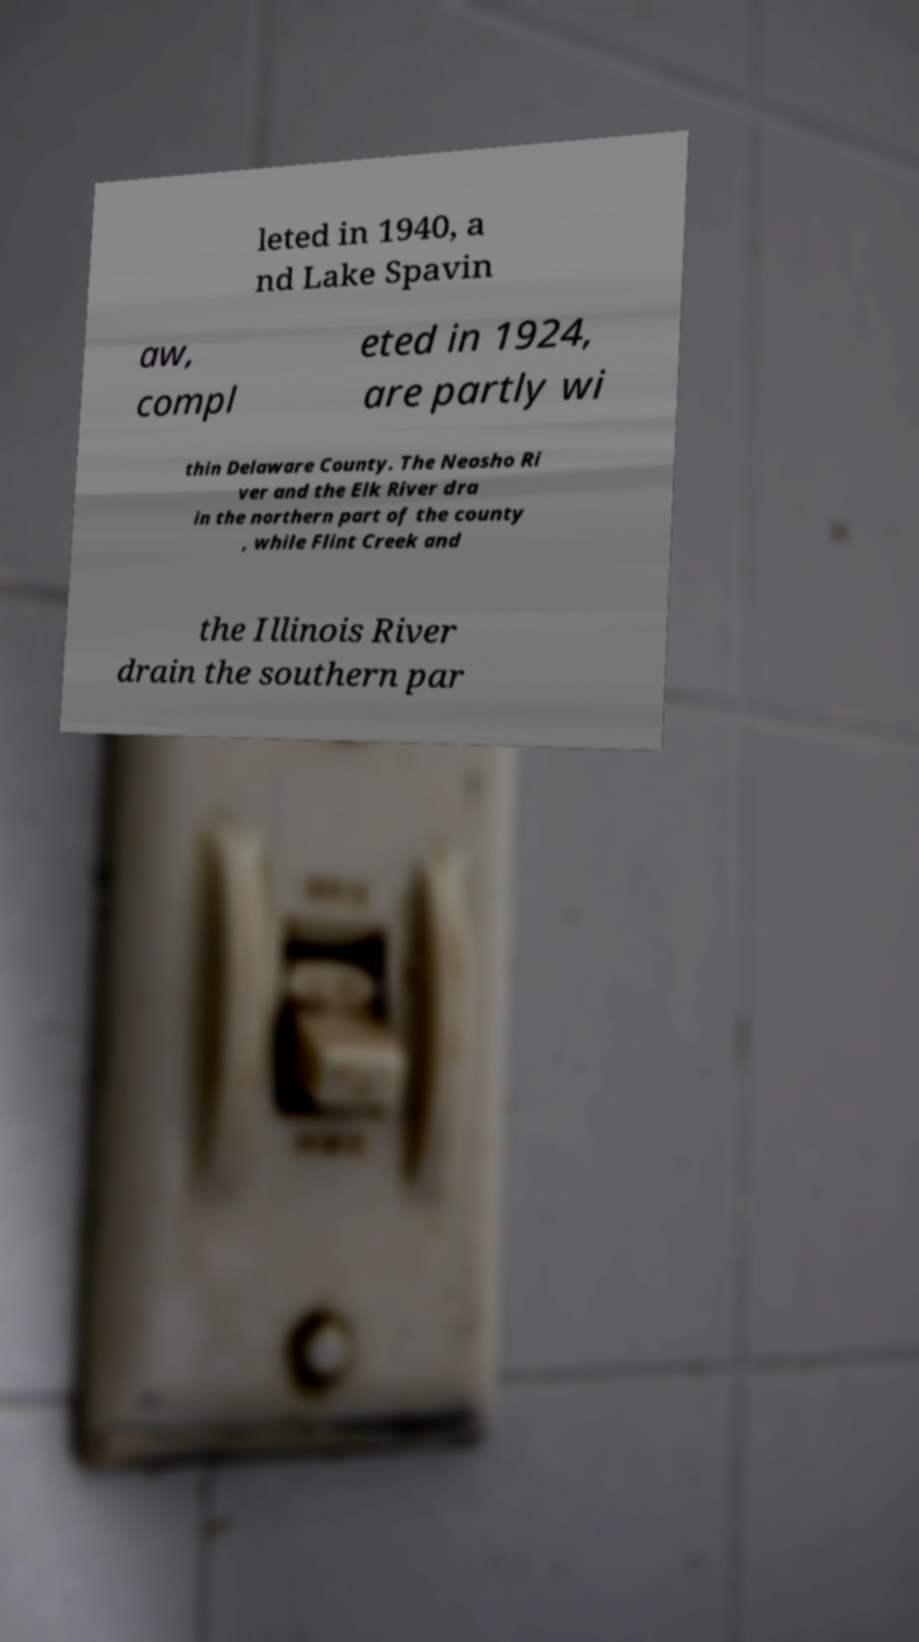Please read and relay the text visible in this image. What does it say? leted in 1940, a nd Lake Spavin aw, compl eted in 1924, are partly wi thin Delaware County. The Neosho Ri ver and the Elk River dra in the northern part of the county , while Flint Creek and the Illinois River drain the southern par 